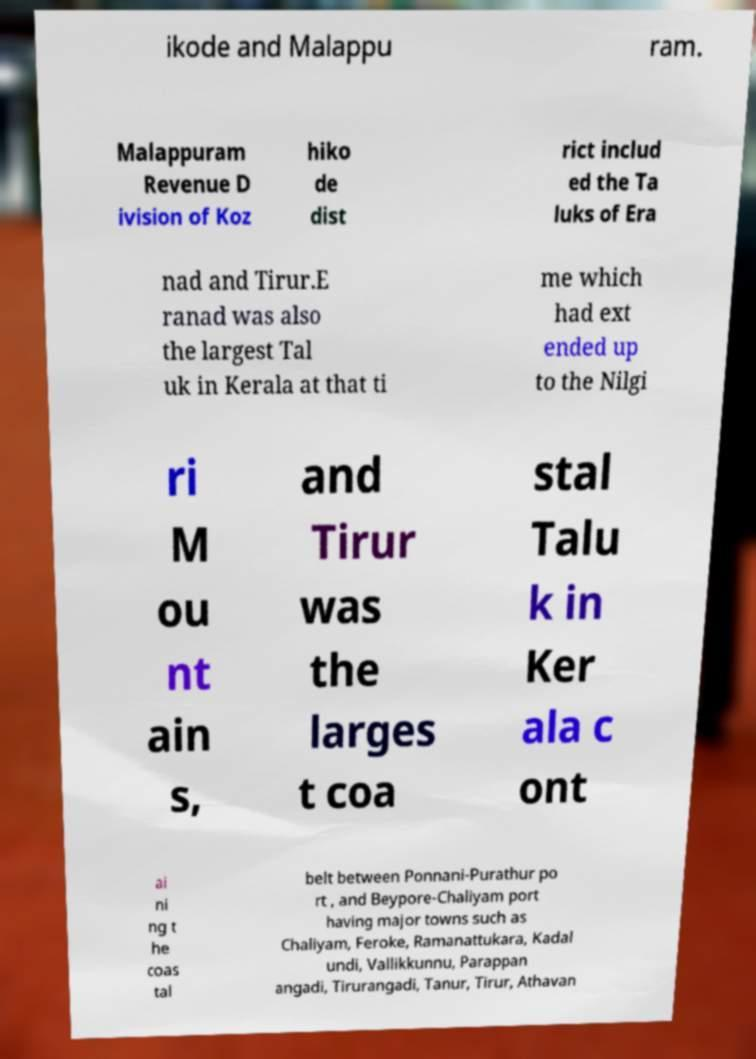Can you accurately transcribe the text from the provided image for me? ikode and Malappu ram. Malappuram Revenue D ivision of Koz hiko de dist rict includ ed the Ta luks of Era nad and Tirur.E ranad was also the largest Tal uk in Kerala at that ti me which had ext ended up to the Nilgi ri M ou nt ain s, and Tirur was the larges t coa stal Talu k in Ker ala c ont ai ni ng t he coas tal belt between Ponnani-Purathur po rt , and Beypore-Chaliyam port having major towns such as Chaliyam, Feroke, Ramanattukara, Kadal undi, Vallikkunnu, Parappan angadi, Tirurangadi, Tanur, Tirur, Athavan 